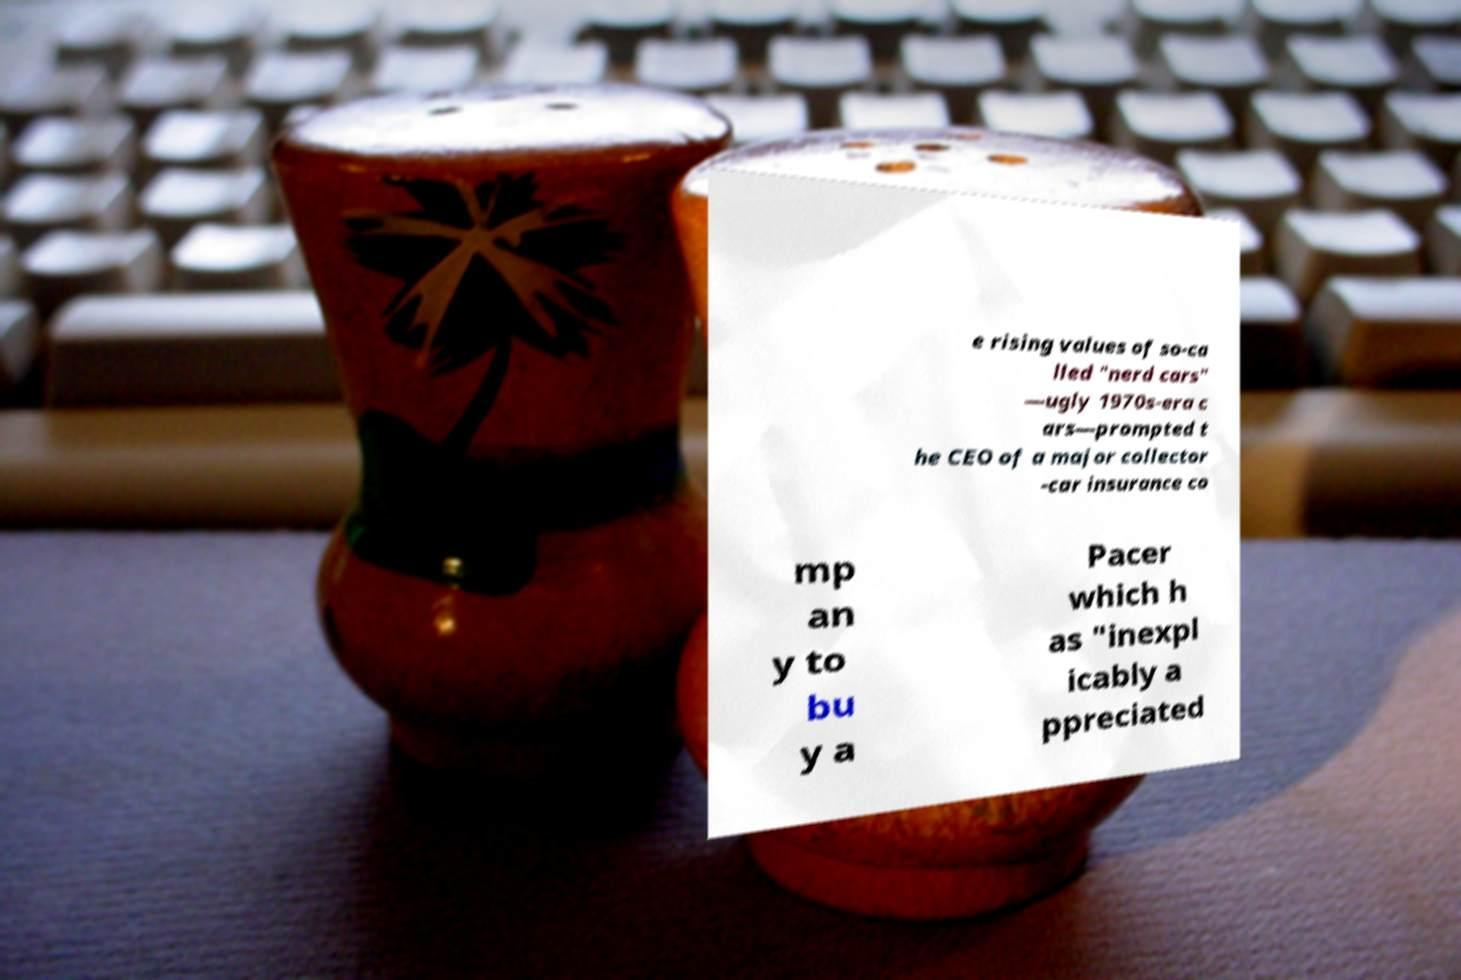What messages or text are displayed in this image? I need them in a readable, typed format. e rising values of so-ca lled "nerd cars" —ugly 1970s-era c ars—prompted t he CEO of a major collector -car insurance co mp an y to bu y a Pacer which h as "inexpl icably a ppreciated 